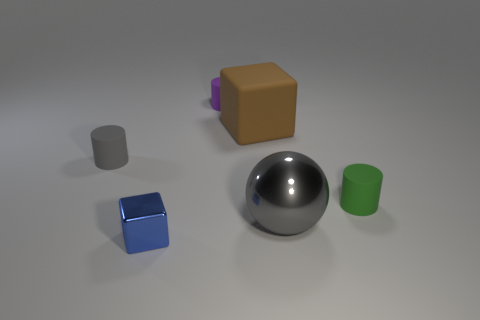Are there the same number of large matte things in front of the tiny blue thing and small gray matte cubes?
Offer a very short reply. Yes. Is there any other thing that has the same material as the purple cylinder?
Offer a very short reply. Yes. Do the shiny sphere and the small thing that is in front of the small green rubber thing have the same color?
Your response must be concise. No. Is there a large brown cube left of the object that is on the right side of the metallic thing on the right side of the small purple cylinder?
Ensure brevity in your answer.  Yes. Are there fewer brown blocks that are behind the brown matte cube than gray balls?
Ensure brevity in your answer.  Yes. How many other things are there of the same shape as the small green matte object?
Make the answer very short. 2. What number of things are either small objects on the left side of the green rubber cylinder or objects that are in front of the small green thing?
Ensure brevity in your answer.  4. There is a cylinder that is in front of the purple thing and on the left side of the green matte thing; how big is it?
Offer a very short reply. Small. There is a rubber thing behind the big brown matte object; does it have the same shape as the blue thing?
Provide a short and direct response. No. What size is the cube that is on the left side of the cylinder that is behind the large object that is behind the large gray metal ball?
Ensure brevity in your answer.  Small. 